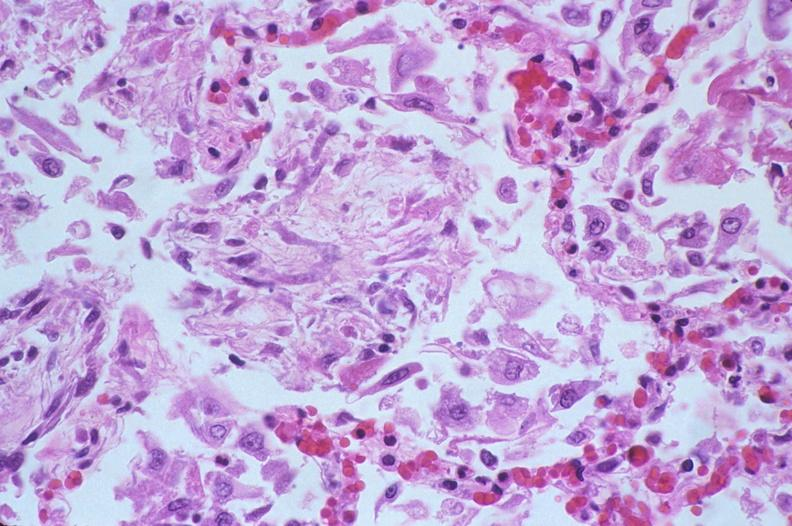where is this?
Answer the question using a single word or phrase. Lung 